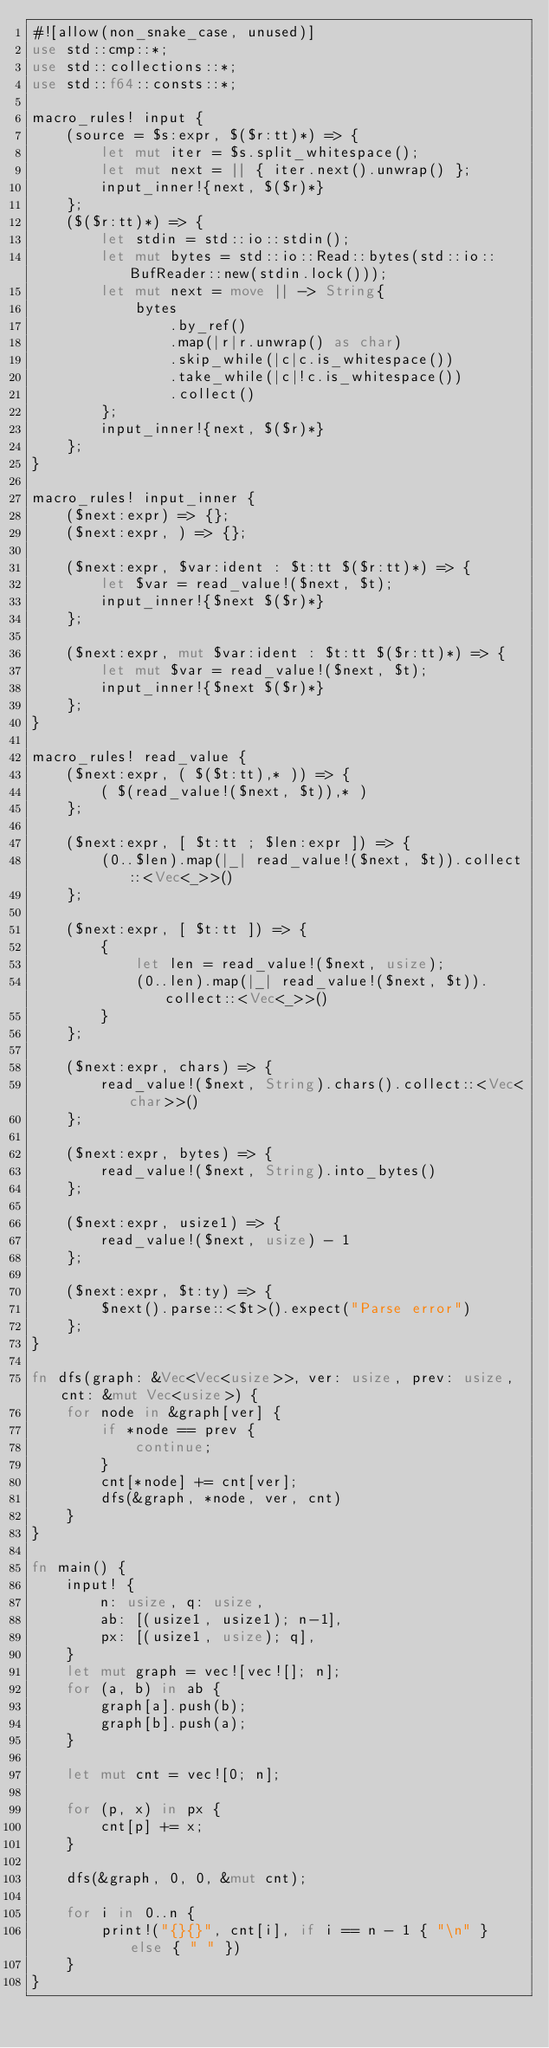<code> <loc_0><loc_0><loc_500><loc_500><_Rust_>#![allow(non_snake_case, unused)]
use std::cmp::*;
use std::collections::*;
use std::f64::consts::*;

macro_rules! input {
    (source = $s:expr, $($r:tt)*) => {
        let mut iter = $s.split_whitespace();
        let mut next = || { iter.next().unwrap() };
        input_inner!{next, $($r)*}
    };
    ($($r:tt)*) => {
        let stdin = std::io::stdin();
        let mut bytes = std::io::Read::bytes(std::io::BufReader::new(stdin.lock()));
        let mut next = move || -> String{
            bytes
                .by_ref()
                .map(|r|r.unwrap() as char)
                .skip_while(|c|c.is_whitespace())
                .take_while(|c|!c.is_whitespace())
                .collect()
        };
        input_inner!{next, $($r)*}
    };
}

macro_rules! input_inner {
    ($next:expr) => {};
    ($next:expr, ) => {};

    ($next:expr, $var:ident : $t:tt $($r:tt)*) => {
        let $var = read_value!($next, $t);
        input_inner!{$next $($r)*}
    };

    ($next:expr, mut $var:ident : $t:tt $($r:tt)*) => {
        let mut $var = read_value!($next, $t);
        input_inner!{$next $($r)*}
    };
}

macro_rules! read_value {
    ($next:expr, ( $($t:tt),* )) => {
        ( $(read_value!($next, $t)),* )
    };

    ($next:expr, [ $t:tt ; $len:expr ]) => {
        (0..$len).map(|_| read_value!($next, $t)).collect::<Vec<_>>()
    };

    ($next:expr, [ $t:tt ]) => {
        {
            let len = read_value!($next, usize);
            (0..len).map(|_| read_value!($next, $t)).collect::<Vec<_>>()
        }
    };

    ($next:expr, chars) => {
        read_value!($next, String).chars().collect::<Vec<char>>()
    };

    ($next:expr, bytes) => {
        read_value!($next, String).into_bytes()
    };

    ($next:expr, usize1) => {
        read_value!($next, usize) - 1
    };

    ($next:expr, $t:ty) => {
        $next().parse::<$t>().expect("Parse error")
    };
}

fn dfs(graph: &Vec<Vec<usize>>, ver: usize, prev: usize, cnt: &mut Vec<usize>) {
    for node in &graph[ver] {
        if *node == prev {
            continue;
        }
        cnt[*node] += cnt[ver];
        dfs(&graph, *node, ver, cnt)
    }
}

fn main() {
    input! {
        n: usize, q: usize,
        ab: [(usize1, usize1); n-1],
        px: [(usize1, usize); q],
    }
    let mut graph = vec![vec![]; n];
    for (a, b) in ab {
        graph[a].push(b);
        graph[b].push(a);
    }

    let mut cnt = vec![0; n];

    for (p, x) in px {
        cnt[p] += x;
    }

    dfs(&graph, 0, 0, &mut cnt);

    for i in 0..n {
        print!("{}{}", cnt[i], if i == n - 1 { "\n" } else { " " })
    }
}
</code> 